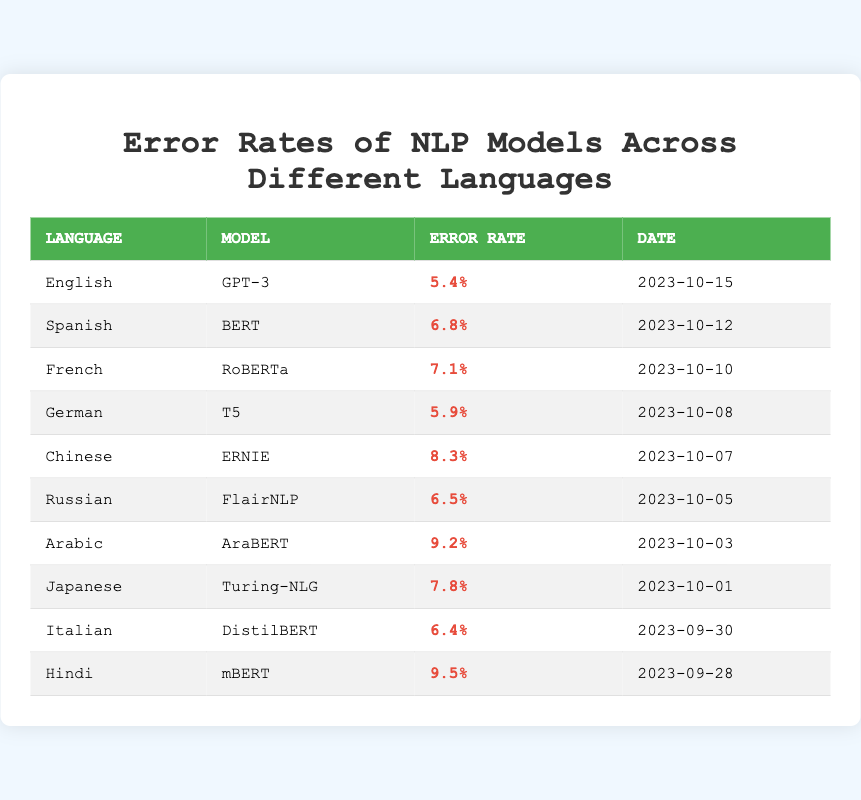What is the error rate for the English model? The table lists each model's error rate, and for English, the model is GPT-3 with an error rate of 5.4%.
Answer: 5.4% Which language has the highest error rate? The error rates are listed, and the highest value is 9.5% for Hindi using the mBERT model.
Answer: Hindi What is the error rate of the Spanish model? The Spanish model is BERT, and its error rate is shown as 6.8%.
Answer: 6.8% How many languages have an error rate greater than 7%? By counting the entries in the table, the languages with error rates greater than 7% are Chinese, Arabic, and Hindi, totaling three languages.
Answer: 3 Is the error rate of T5 higher than 6%? T5's error rate for German is listed as 5.9%, which is not higher than 6%.
Answer: No What is the difference in error rate between the Arabic and Japanese models? The error rate for Arabic (9.2%) minus the error rate for Japanese (7.8%) equals 1.4%, showing that Arabic has a higher error rate.
Answer: 1.4% What is the average error rate of the models listed? Adding all the error rates: 5.4 + 6.8 + 7.1 + 5.9 + 8.3 + 6.5 + 9.2 + 7.8 + 6.4 + 9.5 gives a total of 70.5%. There are 10 models, so the average is 70.5% / 10 = 7.05%.
Answer: 7.05% How many models have error rates below 7%? The models with error rates below 7% are English (5.4%), German (5.9%), and Italian (6.4%), totaling three models.
Answer: 3 Is there a model that has an error rate of exactly 8%? The error rates show that none of the models has an error rate of exactly 8%.
Answer: No Which model had the error rate recorded most recently? The most recent date, October 15, 2023, refers to the error rate for the English model (GPT-3) at 5.4%.
Answer: GPT-3 